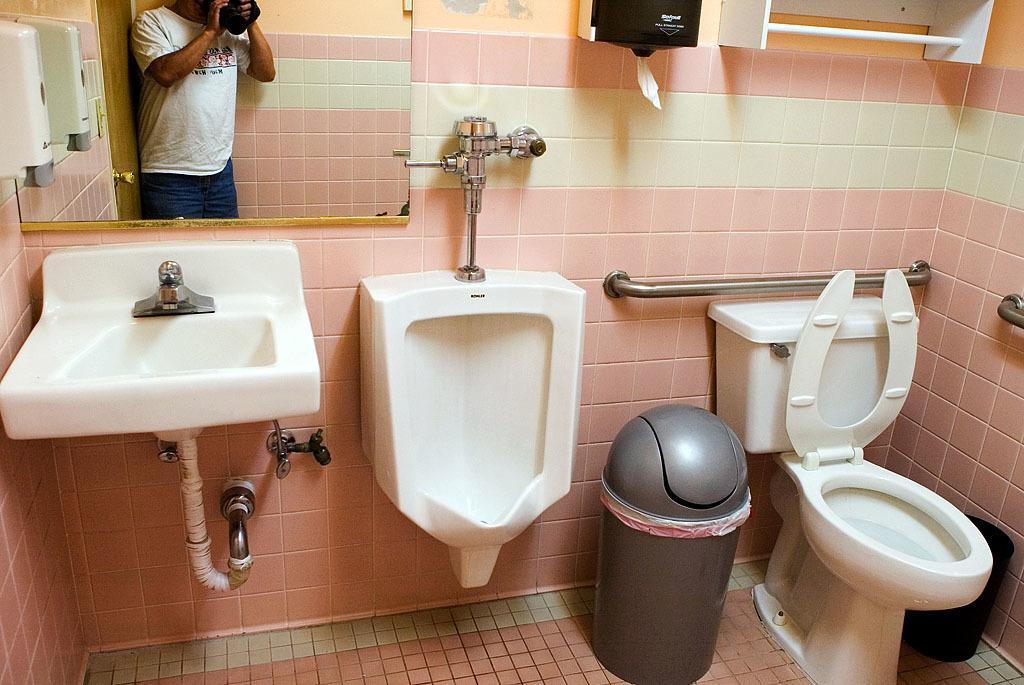Please provide a concise description of this image. This picture is clicked inside the room. On the right we can see the toilet seat and we can see the wash basin and we can see a tap attached to the wash basin and we can see the dustbins are placed on the ground and we can see a urinal and some other objects are attached to the wall and we can see a wall mounted mirror in which we can see the reflection of a person wearing white color t-shirt, holding some object and standing and we can see the reflection of a wooden door and we can see the metal rods and some other objects. 